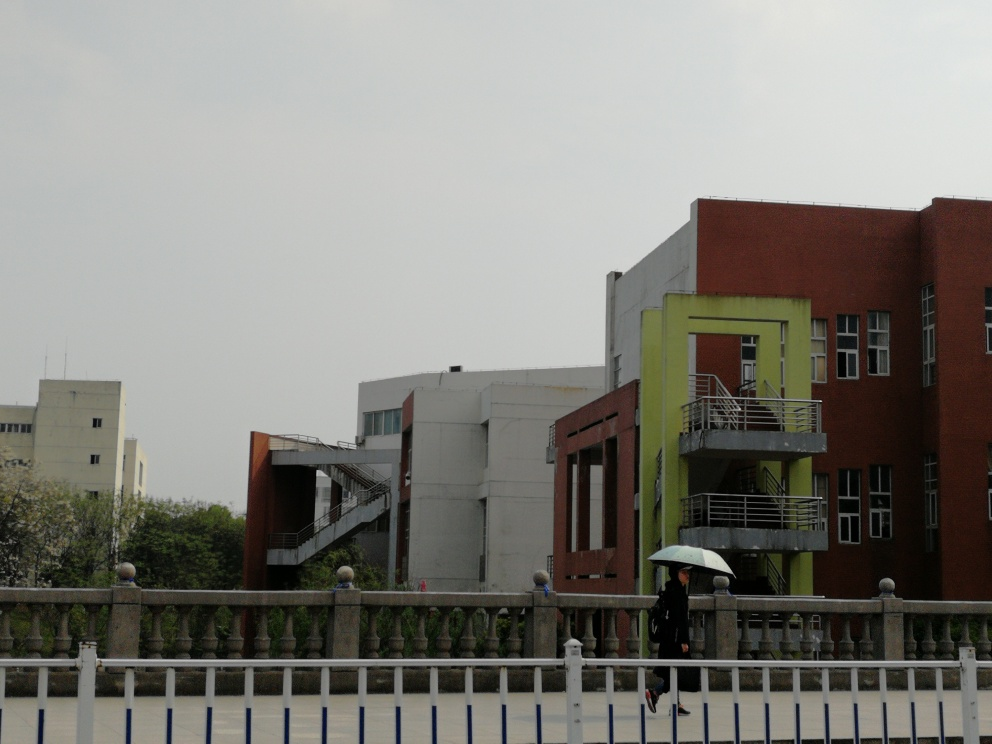Is there anything in the image that indicates the location or cultural setting? While there are no overt cultural symbols, the architectural style of the buildings suggests a contemporary urban environment that could be found in many regions around the world. The use of certain colors and the presence of the railing design might hint at specific regional preferences, yet there's not enough context to determine a precise location. 